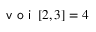Convert formula to latex. <formula><loc_0><loc_0><loc_500><loc_500>v o i \left [ 2 , 3 \right ] = 4</formula> 